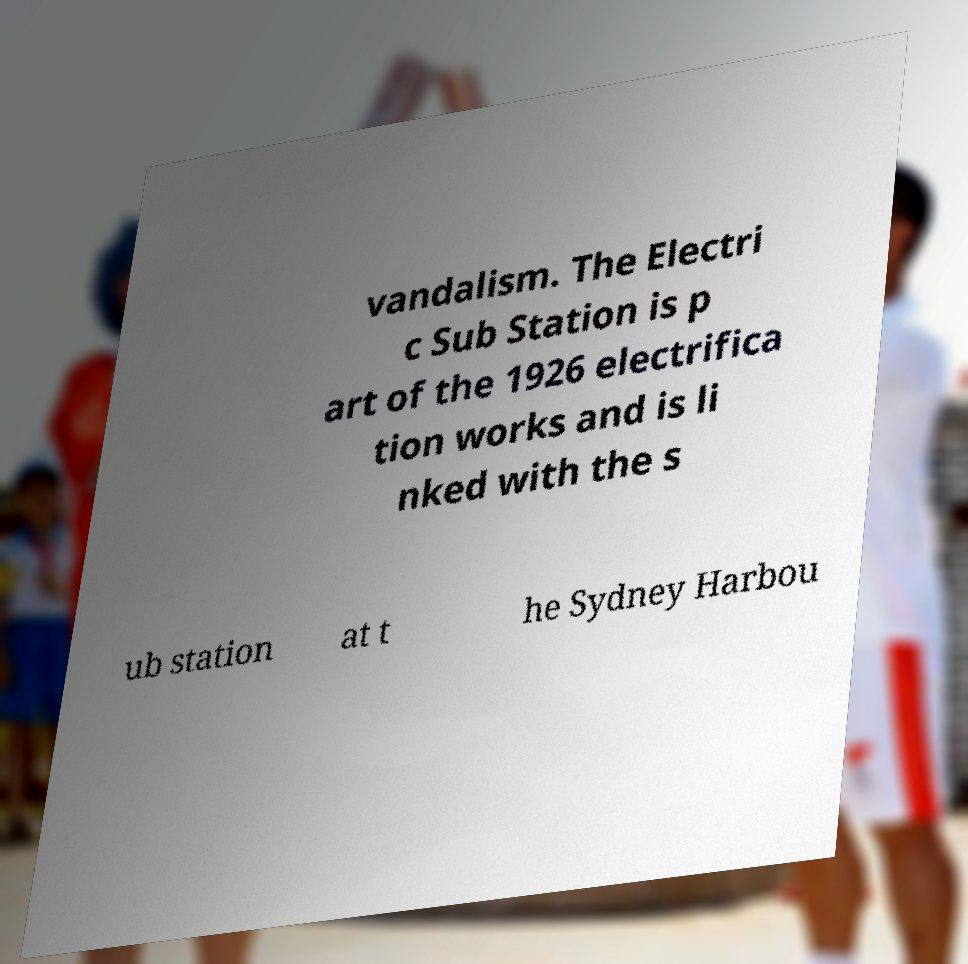Please identify and transcribe the text found in this image. vandalism. The Electri c Sub Station is p art of the 1926 electrifica tion works and is li nked with the s ub station at t he Sydney Harbou 